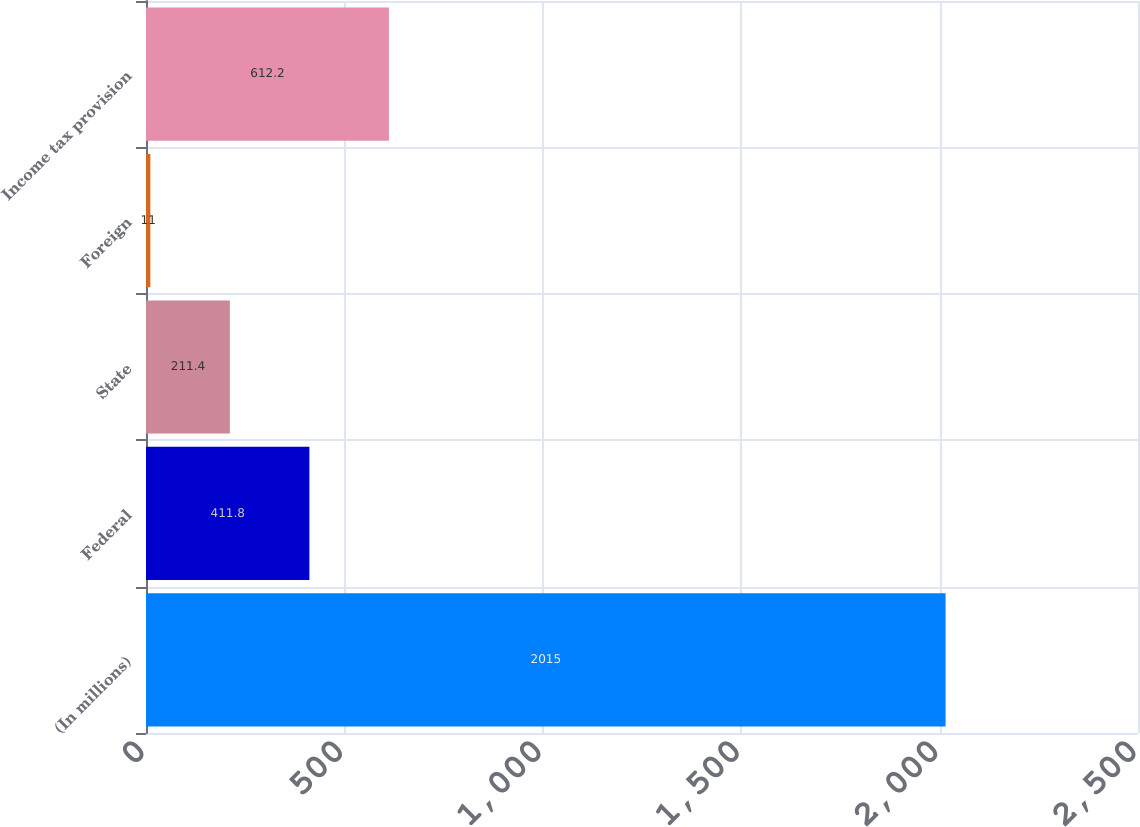<chart> <loc_0><loc_0><loc_500><loc_500><bar_chart><fcel>(In millions)<fcel>Federal<fcel>State<fcel>Foreign<fcel>Income tax provision<nl><fcel>2015<fcel>411.8<fcel>211.4<fcel>11<fcel>612.2<nl></chart> 